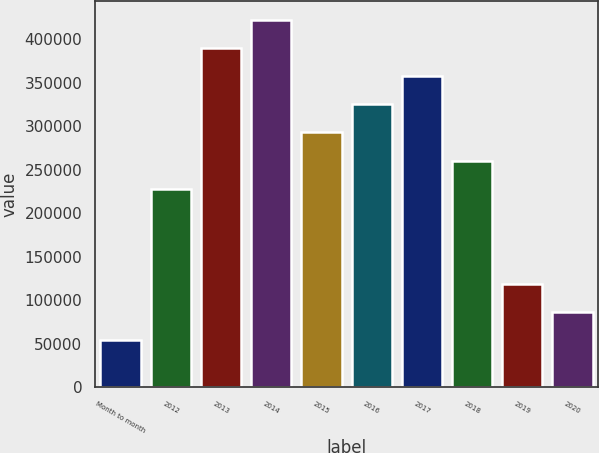<chart> <loc_0><loc_0><loc_500><loc_500><bar_chart><fcel>Month to month<fcel>2012<fcel>2013<fcel>2014<fcel>2015<fcel>2016<fcel>2017<fcel>2018<fcel>2019<fcel>2020<nl><fcel>54000<fcel>228000<fcel>390000<fcel>422400<fcel>292800<fcel>325200<fcel>357600<fcel>260400<fcel>118800<fcel>86400<nl></chart> 